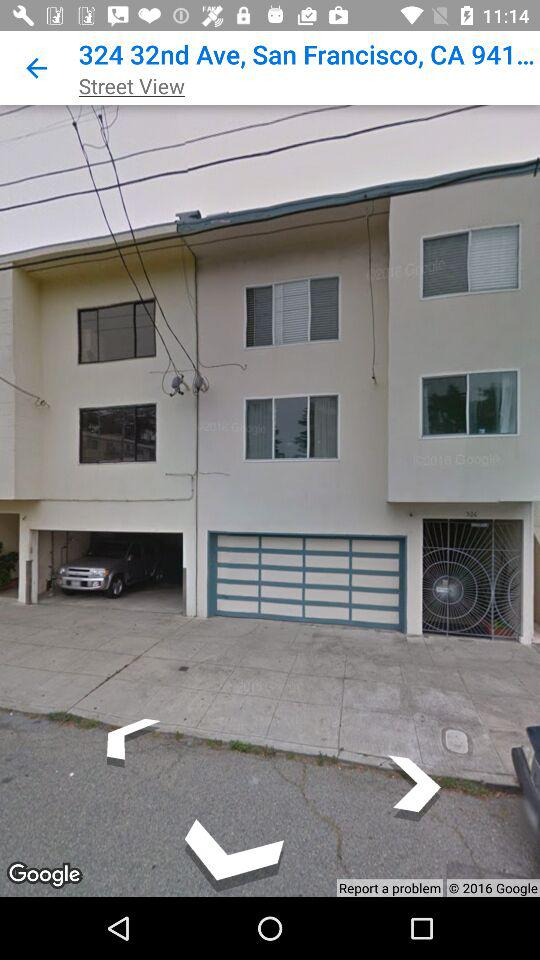Which view is given? The given view is street view. 